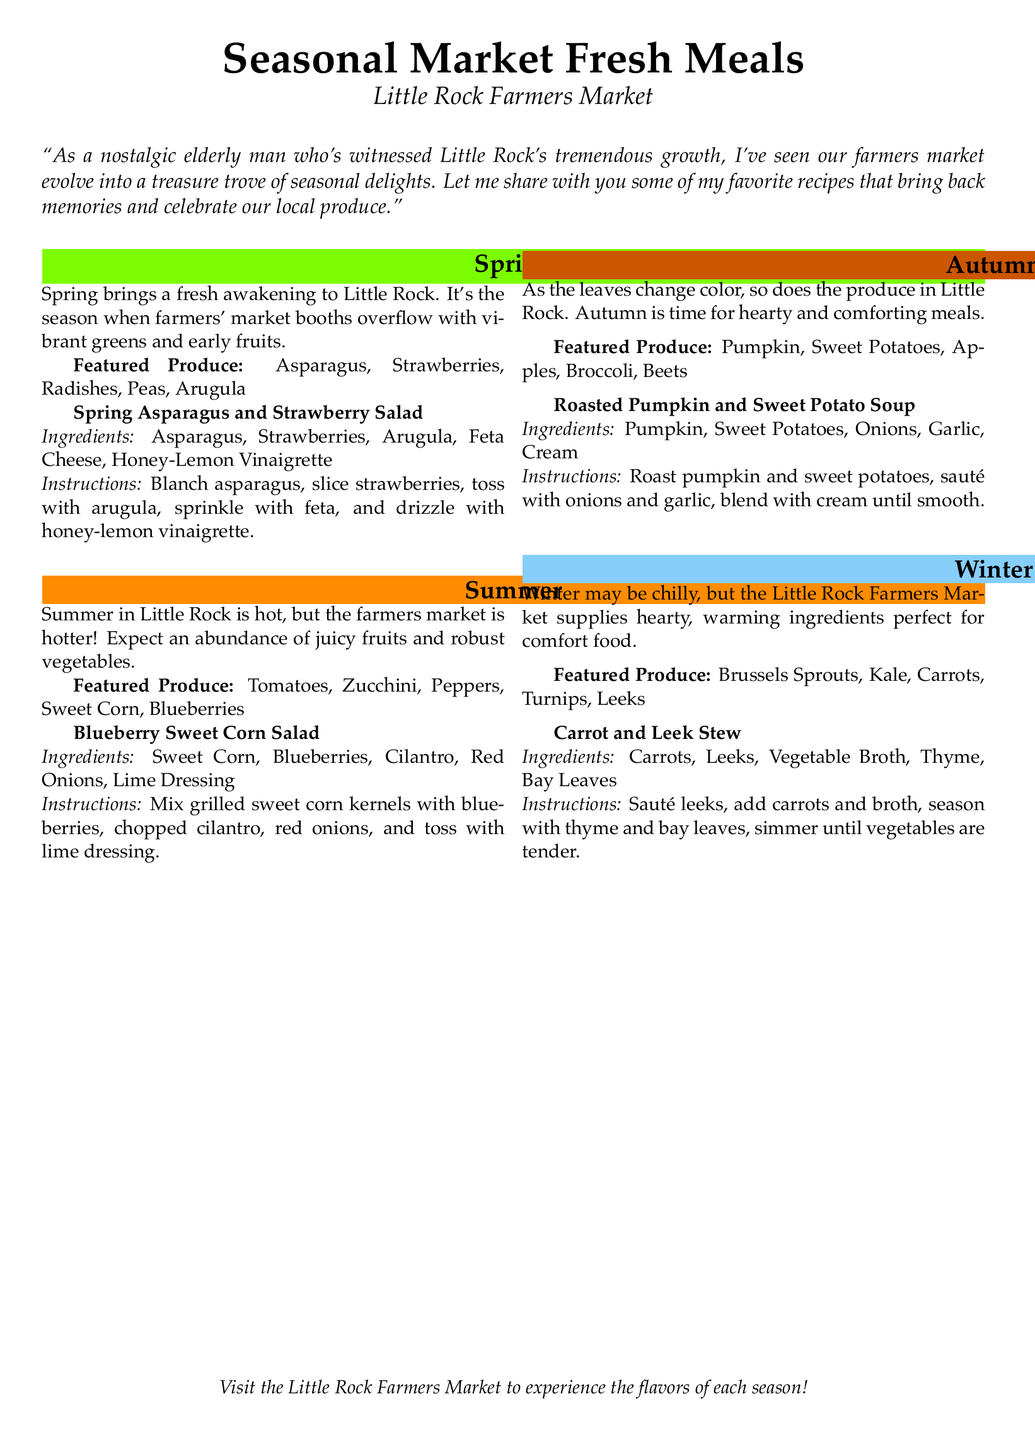What is the featured produce for spring? The featured produce for spring includes Asparagus, Strawberries, Radishes, Peas, and Arugula, as listed in the spring section of the document.
Answer: Asparagus, Strawberries, Radishes, Peas, Arugula How many recipes are included in the meal plan? The meal plan includes four recipes, one for each season, as indicated by the recipe sections for spring, summer, autumn, and winter.
Answer: Four What is the main ingredient in the Roasted Pumpkin and Sweet Potato Soup? The main ingredients listed for the Roasted Pumpkin and Sweet Potato Soup are Pumpkin and Sweet Potatoes, which are essential to the recipe's title.
Answer: Pumpkin, Sweet Potatoes Which season features Blueberries? The document states that Blueberries are featured in the summer section, indicating the seasonal produce availability.
Answer: Summer What type of stew is included in the winter section? The winter section describes a Carrot and Leek Stew based on the recipe provided in that part of the document.
Answer: Carrot and Leek Stew What dressing is used in the Blueberry Sweet Corn Salad? The recipe for Blueberry Sweet Corn Salad specifies the use of Lime Dressing as part of its ingredients.
Answer: Lime Dressing Which ingredients are used in the Spring Asparagus and Strawberry Salad? The ingredients listed for the Spring Asparagus and Strawberry Salad are Asparagus, Strawberries, Arugula, Feta Cheese, and Honey-Lemon Vinaigrette.
Answer: Asparagus, Strawberries, Arugula, Feta Cheese, Honey-Lemon Vinaigrette What is the color associated with autumn? The color defined for autumn in the document is specified as autumn, which is representative of the season's theme.
Answer: autumn 